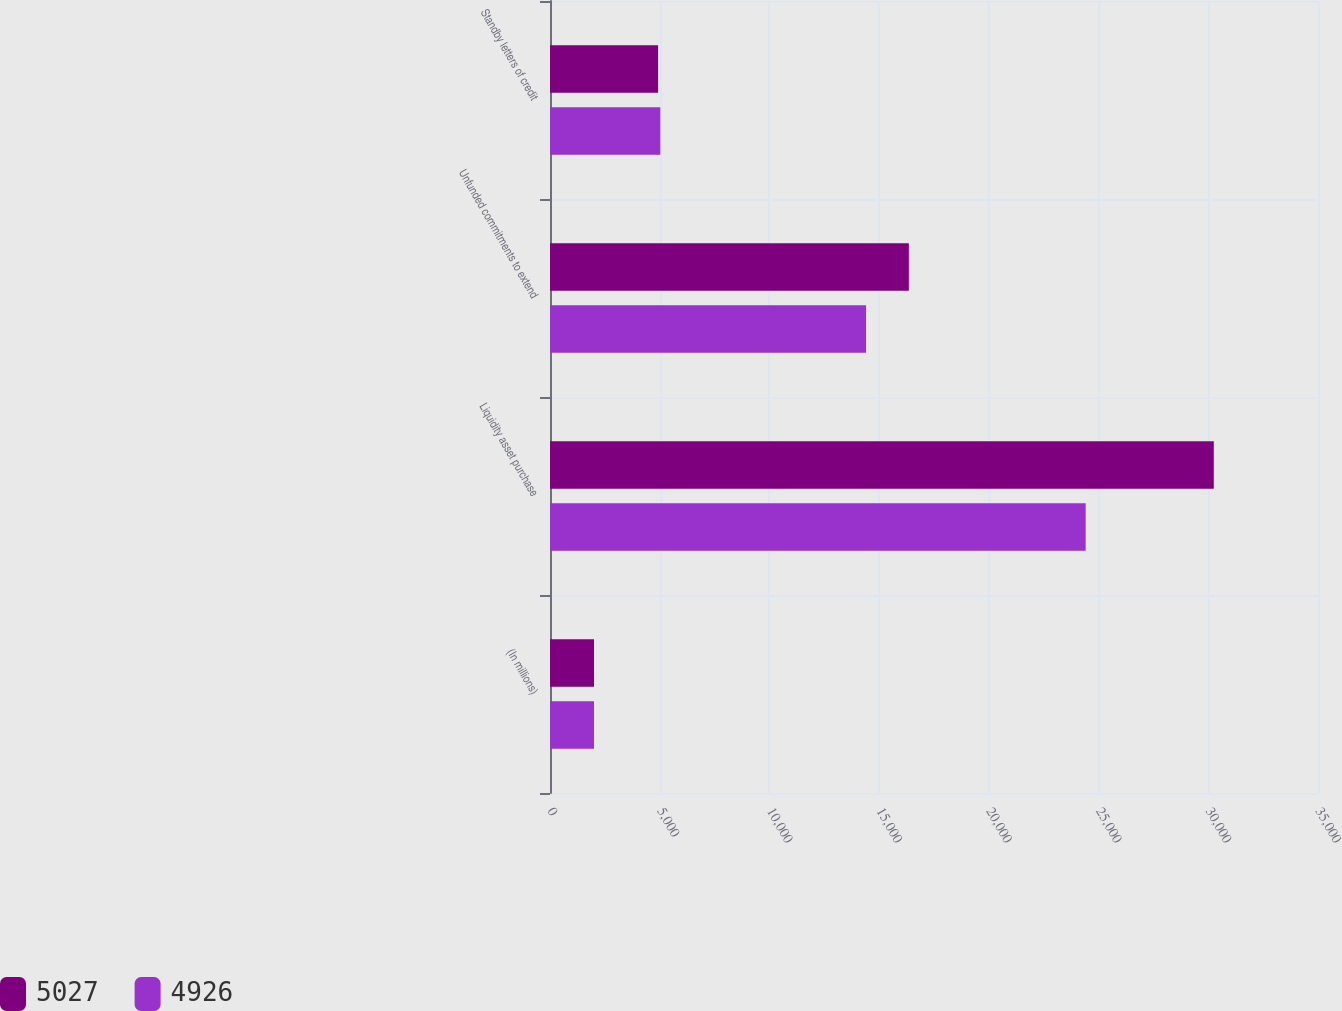<chart> <loc_0><loc_0><loc_500><loc_500><stacked_bar_chart><ecel><fcel>(In millions)<fcel>Liquidity asset purchase<fcel>Unfunded commitments to extend<fcel>Standby letters of credit<nl><fcel>5027<fcel>2006<fcel>30251<fcel>16354<fcel>4926<nl><fcel>4926<fcel>2005<fcel>24412<fcel>14403<fcel>5027<nl></chart> 